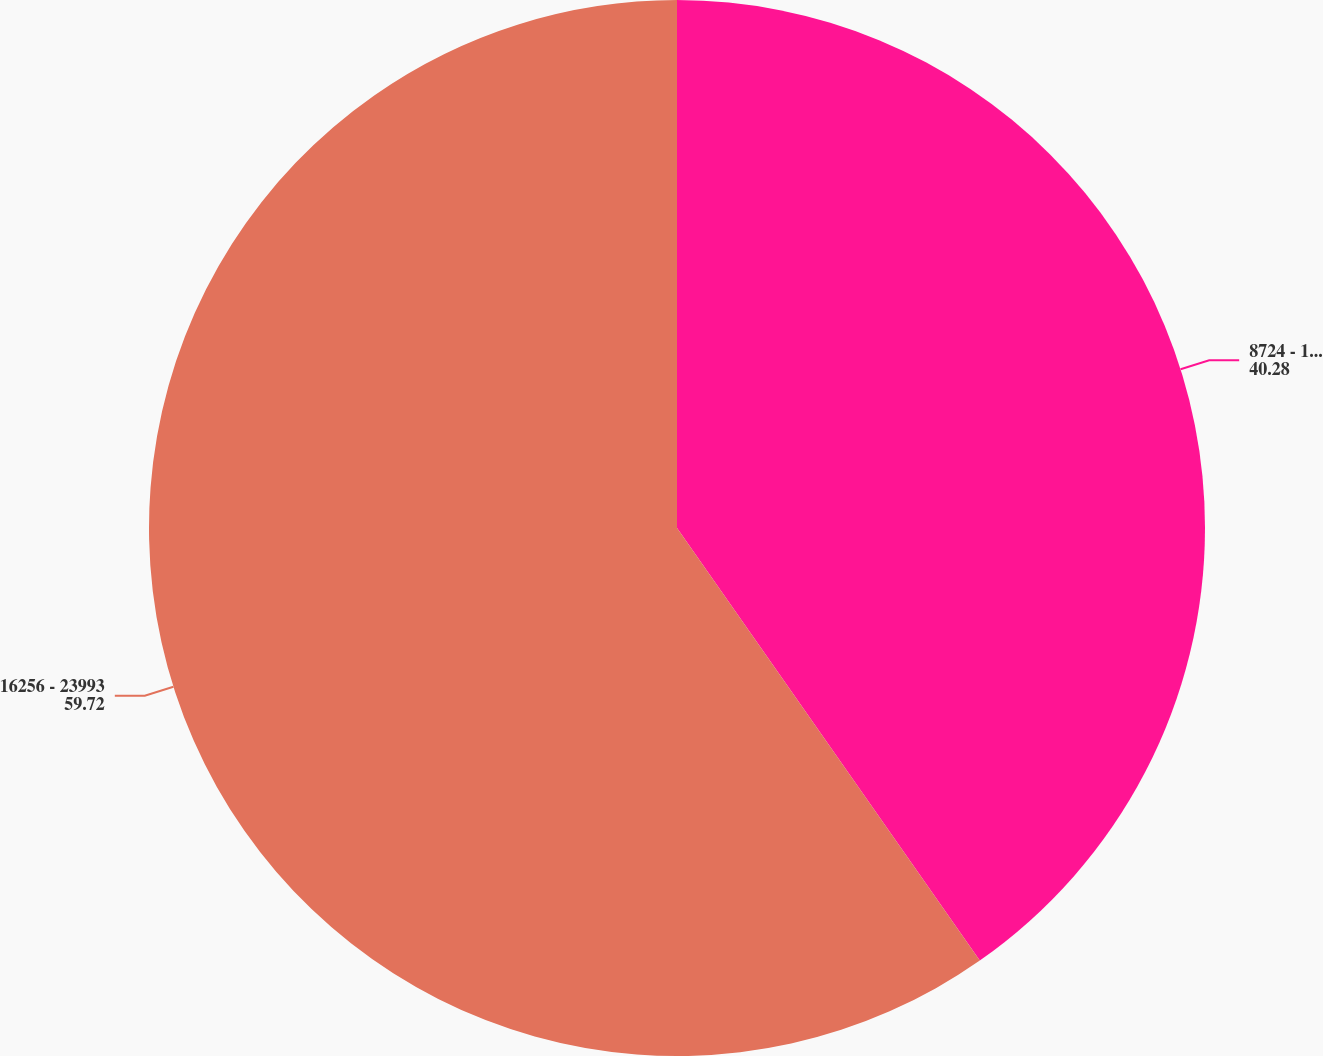<chart> <loc_0><loc_0><loc_500><loc_500><pie_chart><fcel>8724 - 16255<fcel>16256 - 23993<nl><fcel>40.28%<fcel>59.72%<nl></chart> 